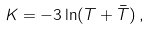<formula> <loc_0><loc_0><loc_500><loc_500>K = - 3 \ln ( T + \bar { T } ) \, ,</formula> 